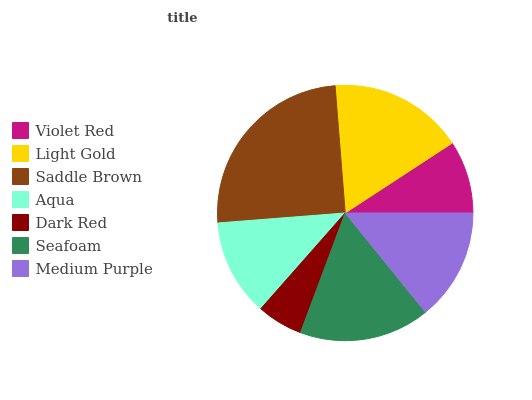Is Dark Red the minimum?
Answer yes or no. Yes. Is Saddle Brown the maximum?
Answer yes or no. Yes. Is Light Gold the minimum?
Answer yes or no. No. Is Light Gold the maximum?
Answer yes or no. No. Is Light Gold greater than Violet Red?
Answer yes or no. Yes. Is Violet Red less than Light Gold?
Answer yes or no. Yes. Is Violet Red greater than Light Gold?
Answer yes or no. No. Is Light Gold less than Violet Red?
Answer yes or no. No. Is Medium Purple the high median?
Answer yes or no. Yes. Is Medium Purple the low median?
Answer yes or no. Yes. Is Saddle Brown the high median?
Answer yes or no. No. Is Aqua the low median?
Answer yes or no. No. 